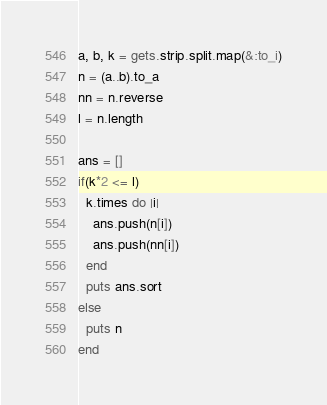<code> <loc_0><loc_0><loc_500><loc_500><_Ruby_>a, b, k = gets.strip.split.map(&:to_i)
n = (a..b).to_a
nn = n.reverse
l = n.length

ans = []
if(k*2 <= l)
  k.times do |i|
    ans.push(n[i])
    ans.push(nn[i])
  end
  puts ans.sort
else
  puts n
end</code> 